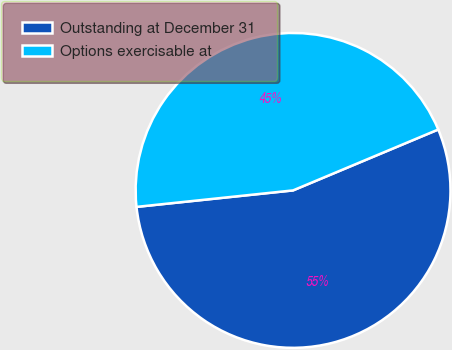Convert chart to OTSL. <chart><loc_0><loc_0><loc_500><loc_500><pie_chart><fcel>Outstanding at December 31<fcel>Options exercisable at<nl><fcel>54.65%<fcel>45.35%<nl></chart> 